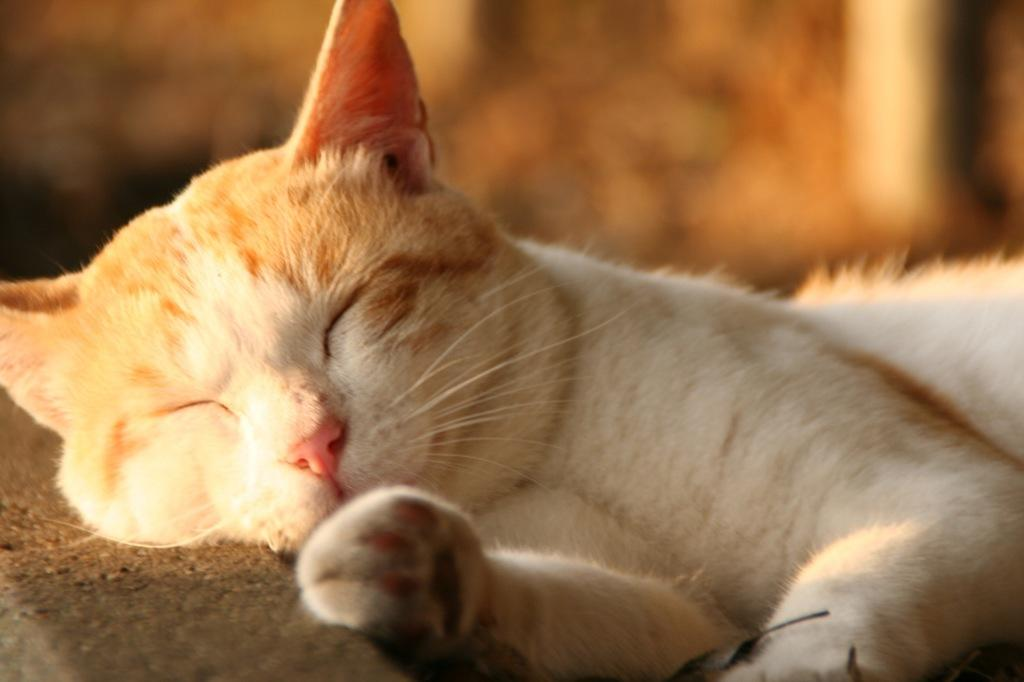What type of animal is in the picture? There is a cat in the picture. Can you describe the color of the cat? The cat has a white and brown color. How is the background of the image depicted? The background of the image is blurred. What type of bean is the cat holding in the picture? There is no bean present in the image, and the cat is not holding anything. 